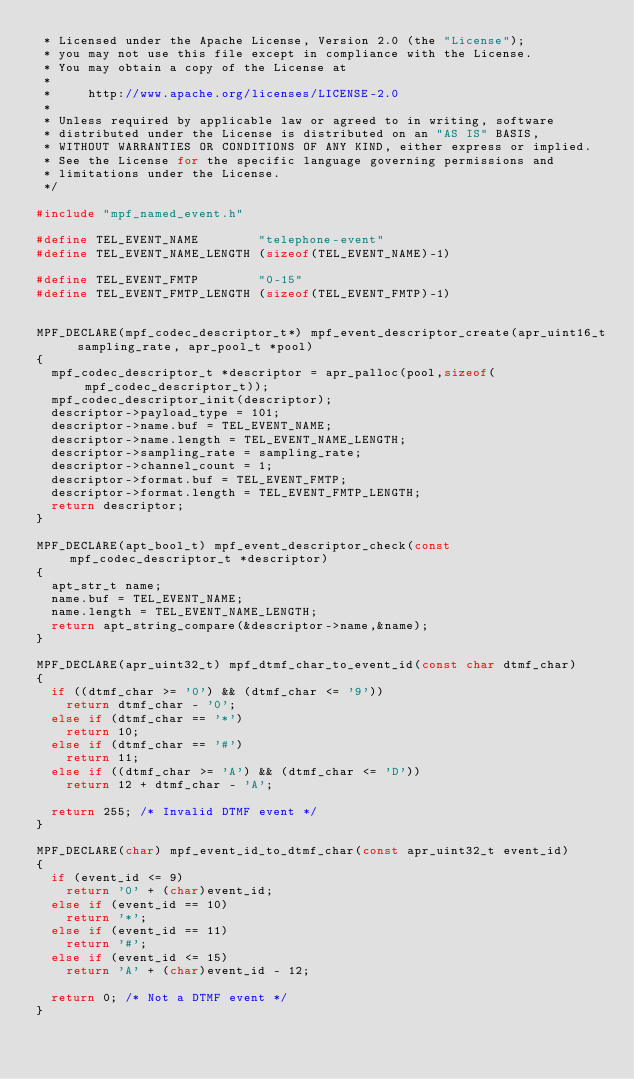<code> <loc_0><loc_0><loc_500><loc_500><_C_> * Licensed under the Apache License, Version 2.0 (the "License");
 * you may not use this file except in compliance with the License.
 * You may obtain a copy of the License at
 *
 *     http://www.apache.org/licenses/LICENSE-2.0
 *
 * Unless required by applicable law or agreed to in writing, software
 * distributed under the License is distributed on an "AS IS" BASIS,
 * WITHOUT WARRANTIES OR CONDITIONS OF ANY KIND, either express or implied.
 * See the License for the specific language governing permissions and
 * limitations under the License.
 */

#include "mpf_named_event.h"

#define TEL_EVENT_NAME        "telephone-event"
#define TEL_EVENT_NAME_LENGTH (sizeof(TEL_EVENT_NAME)-1)

#define TEL_EVENT_FMTP        "0-15"
#define TEL_EVENT_FMTP_LENGTH (sizeof(TEL_EVENT_FMTP)-1)


MPF_DECLARE(mpf_codec_descriptor_t*) mpf_event_descriptor_create(apr_uint16_t sampling_rate, apr_pool_t *pool)
{
	mpf_codec_descriptor_t *descriptor = apr_palloc(pool,sizeof(mpf_codec_descriptor_t));
	mpf_codec_descriptor_init(descriptor);
	descriptor->payload_type = 101;
	descriptor->name.buf = TEL_EVENT_NAME;
	descriptor->name.length = TEL_EVENT_NAME_LENGTH;
	descriptor->sampling_rate = sampling_rate;
	descriptor->channel_count = 1;
	descriptor->format.buf = TEL_EVENT_FMTP;
	descriptor->format.length = TEL_EVENT_FMTP_LENGTH;
	return descriptor;
}

MPF_DECLARE(apt_bool_t) mpf_event_descriptor_check(const mpf_codec_descriptor_t *descriptor)
{
	apt_str_t name;
	name.buf = TEL_EVENT_NAME;
	name.length = TEL_EVENT_NAME_LENGTH;
	return apt_string_compare(&descriptor->name,&name);
}

MPF_DECLARE(apr_uint32_t) mpf_dtmf_char_to_event_id(const char dtmf_char)
{
	if ((dtmf_char >= '0') && (dtmf_char <= '9'))
		return dtmf_char - '0';
	else if (dtmf_char == '*')
		return 10;
	else if (dtmf_char == '#')
		return 11;
	else if ((dtmf_char >= 'A') && (dtmf_char <= 'D'))
		return 12 + dtmf_char - 'A';

	return 255; /* Invalid DTMF event */
}

MPF_DECLARE(char) mpf_event_id_to_dtmf_char(const apr_uint32_t event_id)
{
	if (event_id <= 9)
		return '0' + (char)event_id;
	else if (event_id == 10)
		return '*';
	else if (event_id == 11)
		return '#';
	else if (event_id <= 15)
		return 'A' + (char)event_id - 12;

	return 0; /* Not a DTMF event */
}
</code> 